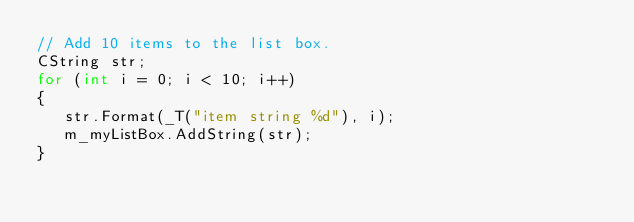Convert code to text. <code><loc_0><loc_0><loc_500><loc_500><_C++_>// Add 10 items to the list box.
CString str;
for (int i = 0; i < 10; i++)
{
   str.Format(_T("item string %d"), i);
   m_myListBox.AddString(str);
}</code> 